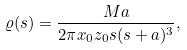<formula> <loc_0><loc_0><loc_500><loc_500>\varrho ( s ) = \frac { M a } { 2 \pi x _ { 0 } z _ { 0 } s ( s + a ) ^ { 3 } } ,</formula> 